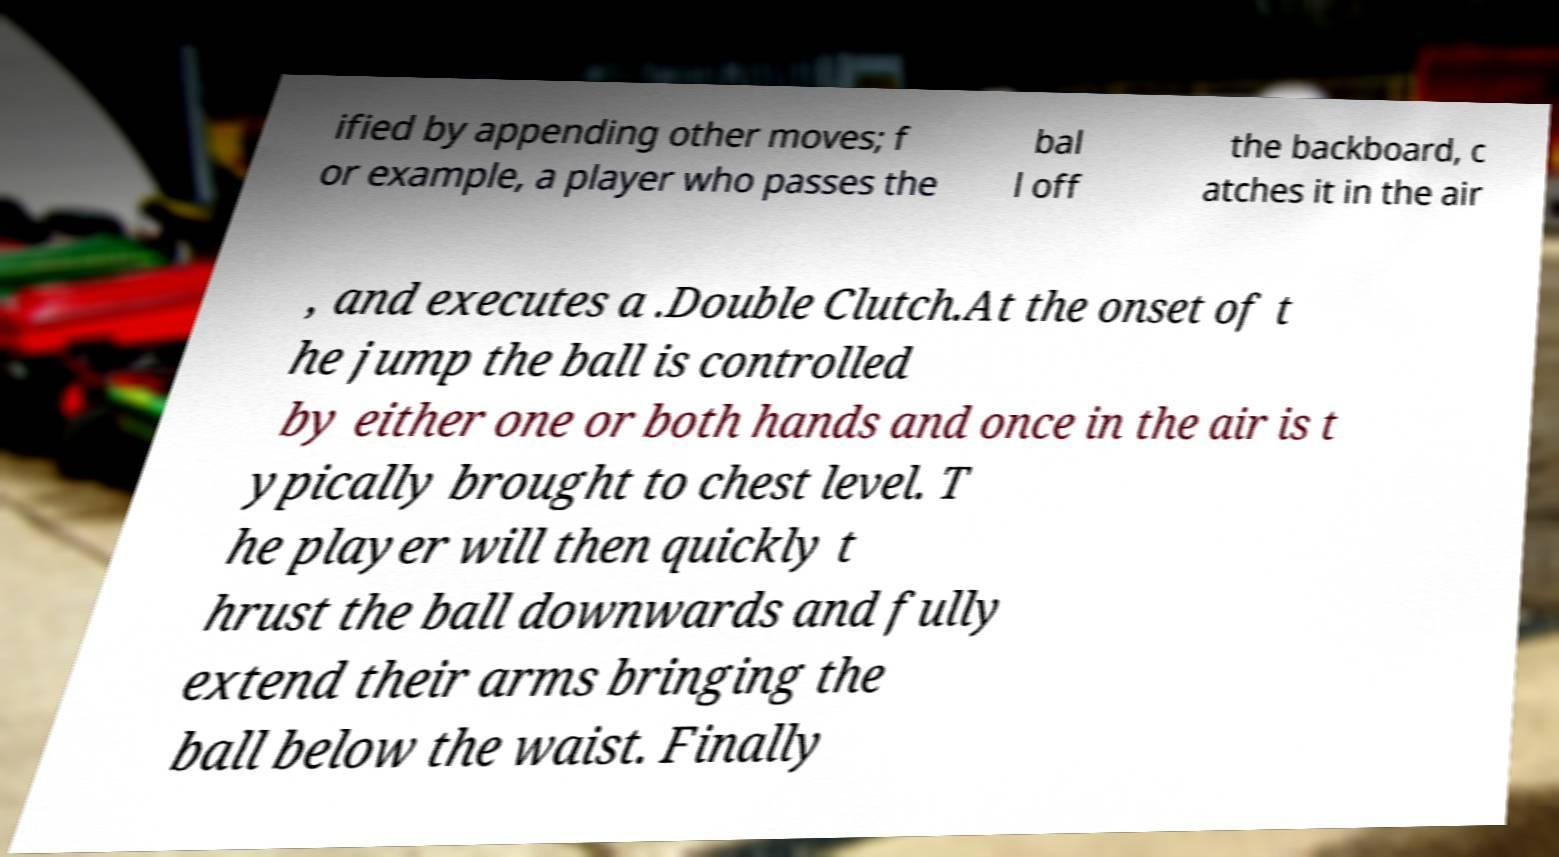Can you accurately transcribe the text from the provided image for me? ified by appending other moves; f or example, a player who passes the bal l off the backboard, c atches it in the air , and executes a .Double Clutch.At the onset of t he jump the ball is controlled by either one or both hands and once in the air is t ypically brought to chest level. T he player will then quickly t hrust the ball downwards and fully extend their arms bringing the ball below the waist. Finally 